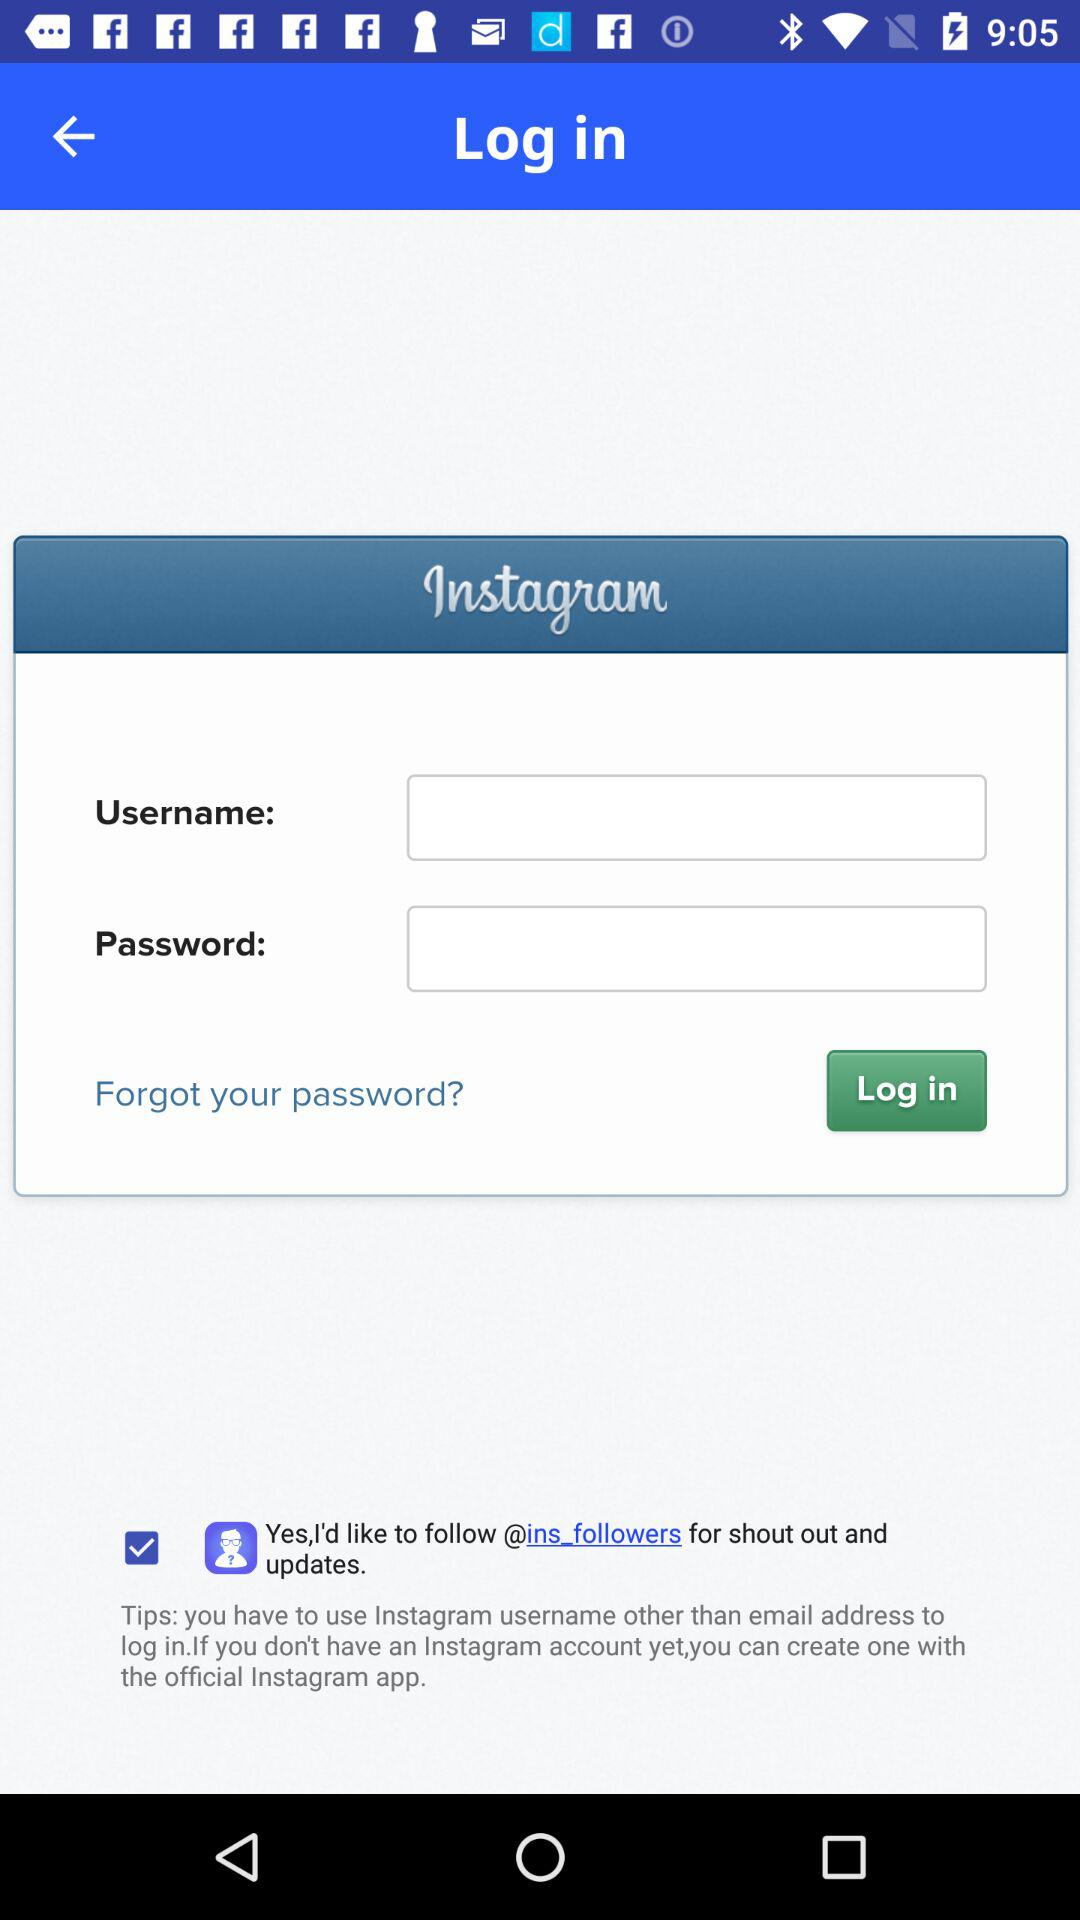How many fields are there to fill in to log in?
Answer the question using a single word or phrase. 2 